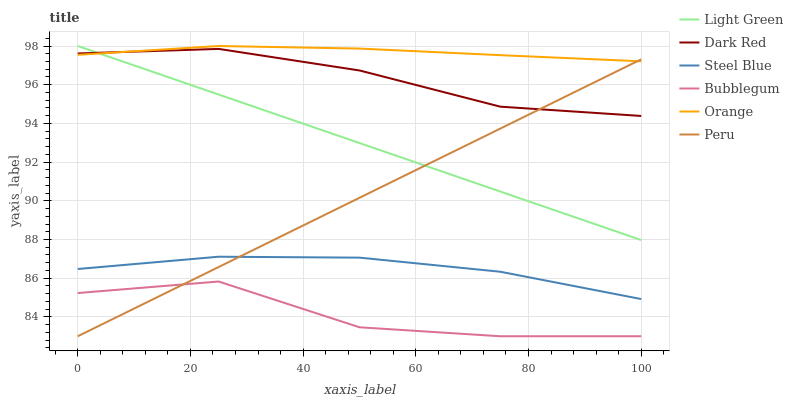Does Bubblegum have the minimum area under the curve?
Answer yes or no. Yes. Does Orange have the maximum area under the curve?
Answer yes or no. Yes. Does Dark Red have the minimum area under the curve?
Answer yes or no. No. Does Dark Red have the maximum area under the curve?
Answer yes or no. No. Is Peru the smoothest?
Answer yes or no. Yes. Is Bubblegum the roughest?
Answer yes or no. Yes. Is Dark Red the smoothest?
Answer yes or no. No. Is Dark Red the roughest?
Answer yes or no. No. Does Bubblegum have the lowest value?
Answer yes or no. Yes. Does Dark Red have the lowest value?
Answer yes or no. No. Does Orange have the highest value?
Answer yes or no. Yes. Does Dark Red have the highest value?
Answer yes or no. No. Is Steel Blue less than Orange?
Answer yes or no. Yes. Is Steel Blue greater than Bubblegum?
Answer yes or no. Yes. Does Peru intersect Orange?
Answer yes or no. Yes. Is Peru less than Orange?
Answer yes or no. No. Is Peru greater than Orange?
Answer yes or no. No. Does Steel Blue intersect Orange?
Answer yes or no. No. 